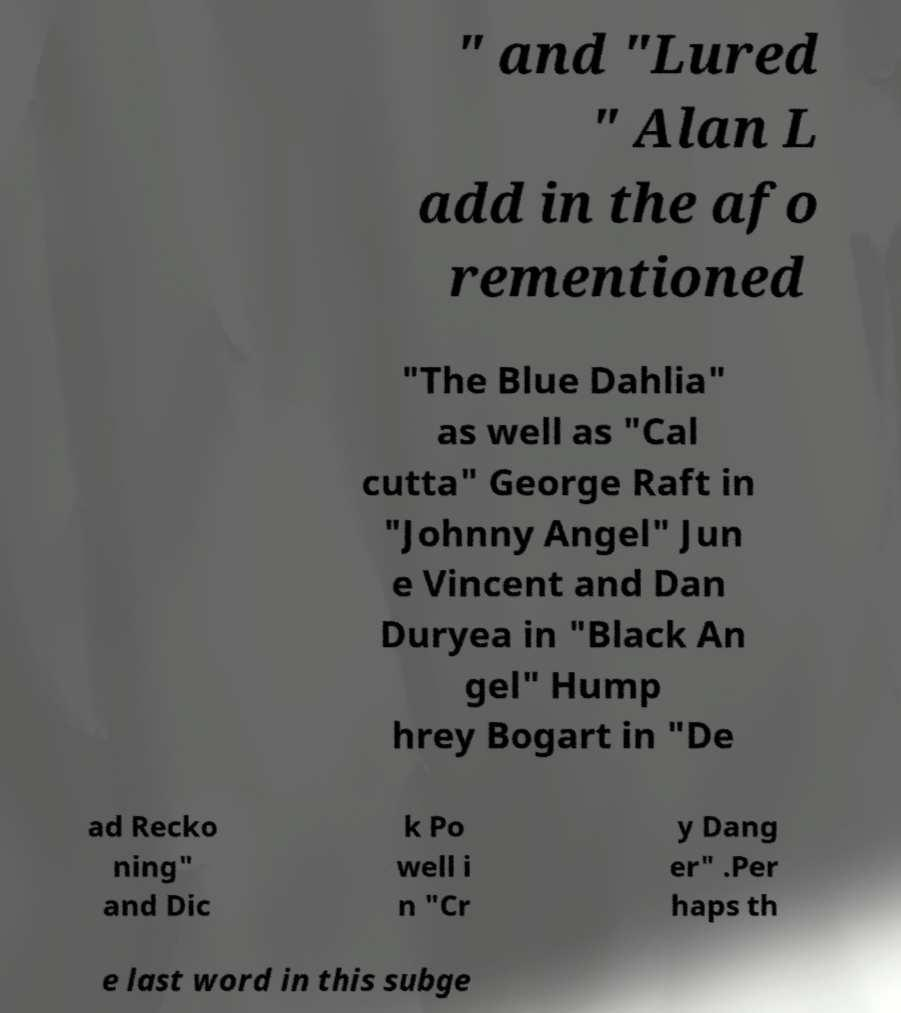I need the written content from this picture converted into text. Can you do that? " and "Lured " Alan L add in the afo rementioned "The Blue Dahlia" as well as "Cal cutta" George Raft in "Johnny Angel" Jun e Vincent and Dan Duryea in "Black An gel" Hump hrey Bogart in "De ad Recko ning" and Dic k Po well i n "Cr y Dang er" .Per haps th e last word in this subge 